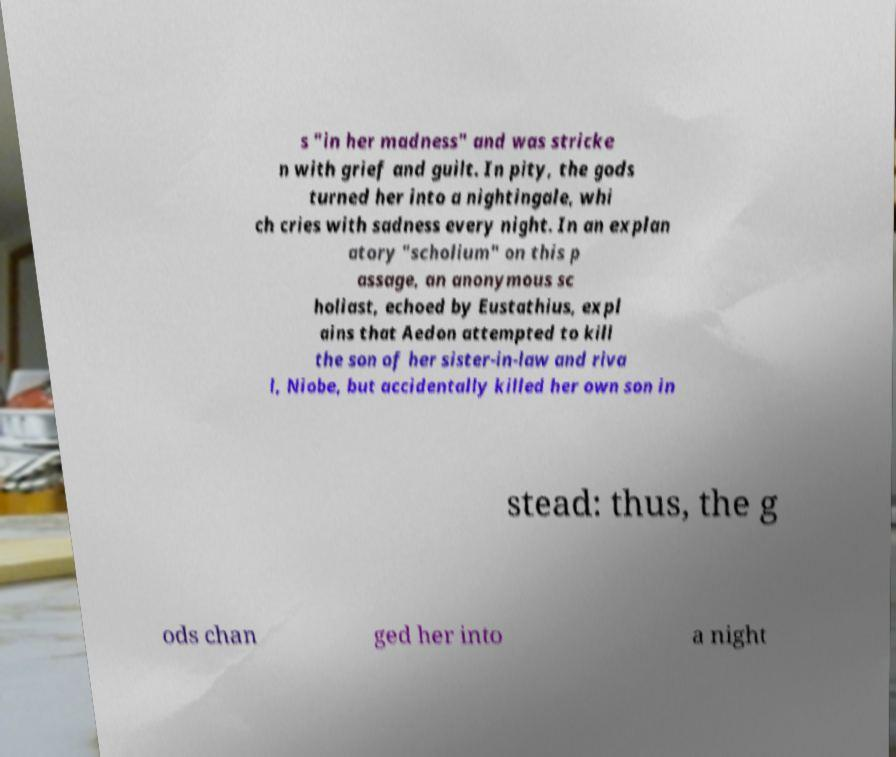I need the written content from this picture converted into text. Can you do that? s "in her madness" and was stricke n with grief and guilt. In pity, the gods turned her into a nightingale, whi ch cries with sadness every night. In an explan atory "scholium" on this p assage, an anonymous sc holiast, echoed by Eustathius, expl ains that Aedon attempted to kill the son of her sister-in-law and riva l, Niobe, but accidentally killed her own son in stead: thus, the g ods chan ged her into a night 